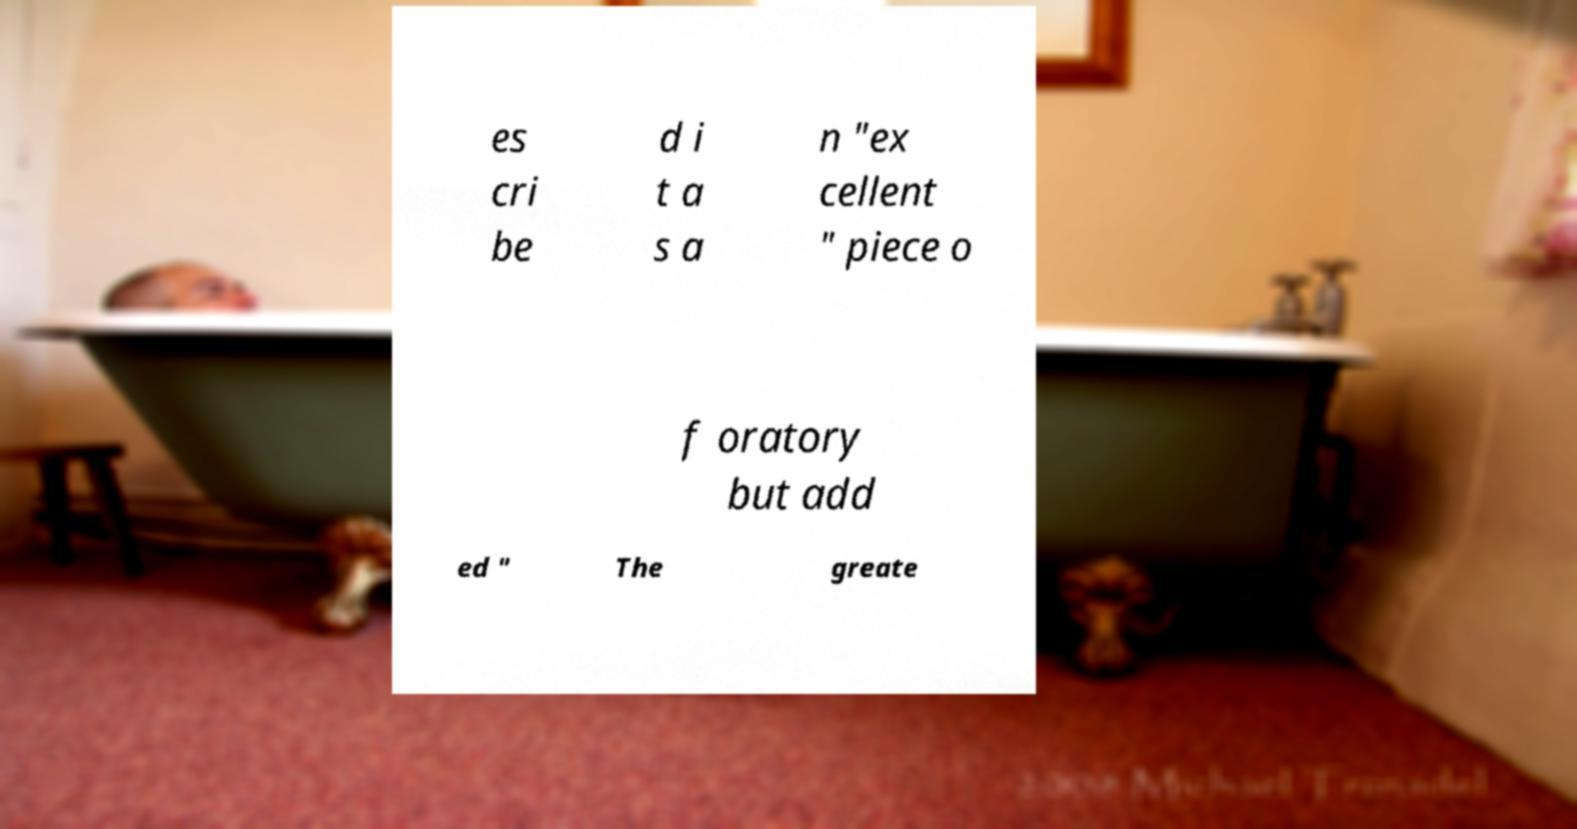Can you read and provide the text displayed in the image?This photo seems to have some interesting text. Can you extract and type it out for me? es cri be d i t a s a n "ex cellent " piece o f oratory but add ed " The greate 